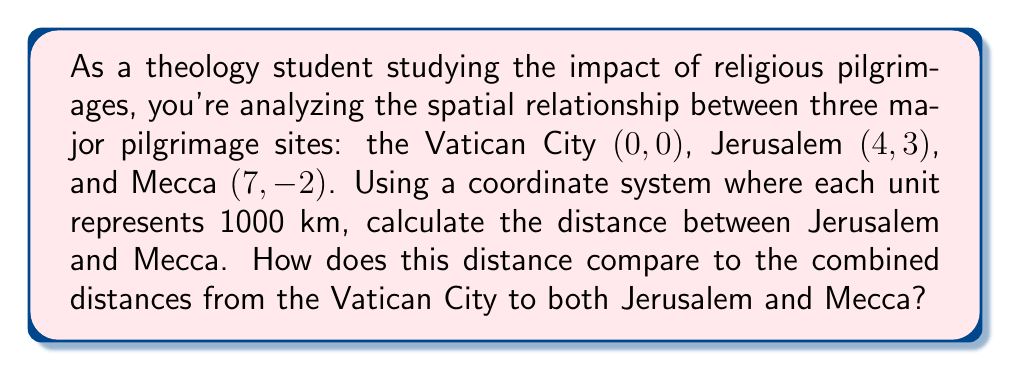Give your solution to this math problem. To solve this problem, we'll use the distance formula derived from the Pythagorean theorem. For two points $(x_1, y_1)$ and $(x_2, y_2)$, the distance is given by:

$$d = \sqrt{(x_2 - x_1)^2 + (y_2 - y_1)^2}$$

1. Calculate the distance between Jerusalem (4, 3) and Mecca (7, -2):
   $$d_{JM} = \sqrt{(7 - 4)^2 + (-2 - 3)^2} = \sqrt{3^2 + (-5)^2} = \sqrt{9 + 25} = \sqrt{34} \approx 5.83$$

2. Calculate the distance between Vatican City (0, 0) and Jerusalem (4, 3):
   $$d_{VJ} = \sqrt{(4 - 0)^2 + (3 - 0)^2} = \sqrt{4^2 + 3^2} = \sqrt{16 + 9} = \sqrt{25} = 5$$

3. Calculate the distance between Vatican City (0, 0) and Mecca (7, -2):
   $$d_{VM} = \sqrt{(7 - 0)^2 + (-2 - 0)^2} = \sqrt{7^2 + (-2)^2} = \sqrt{49 + 4} = \sqrt{53} \approx 7.28$$

4. Compare the distances:
   - Distance between Jerusalem and Mecca: $5.83 \times 1000 = 5830$ km
   - Combined distances from Vatican City to Jerusalem and Mecca: 
     $(5 + 7.28) \times 1000 = 12280$ km

The distance between Jerusalem and Mecca (5830 km) is less than half the combined distances from the Vatican City to both Jerusalem and Mecca (12280 km).
Answer: The distance between Jerusalem and Mecca is approximately 5830 km. This distance is less than half the combined distances from the Vatican City to both Jerusalem and Mecca, which is 12280 km. 